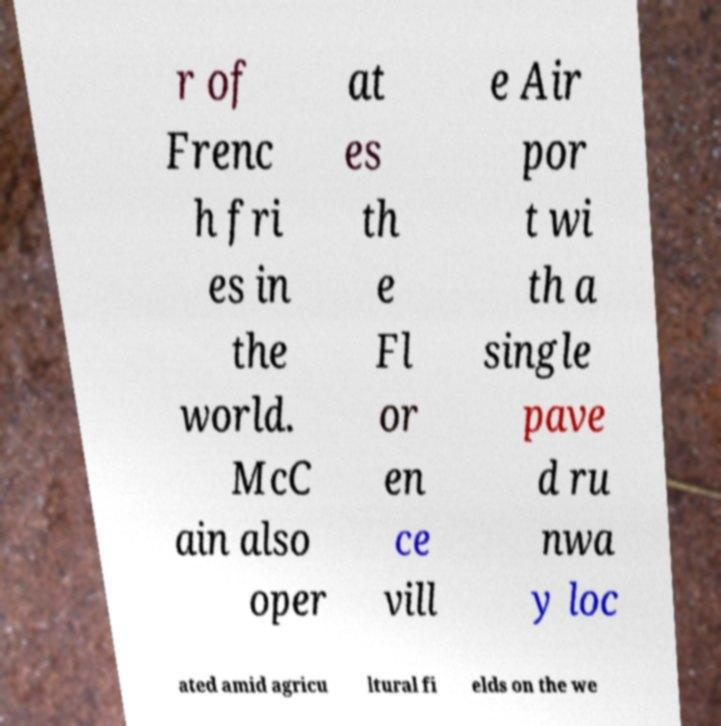Could you extract and type out the text from this image? r of Frenc h fri es in the world. McC ain also oper at es th e Fl or en ce vill e Air por t wi th a single pave d ru nwa y loc ated amid agricu ltural fi elds on the we 